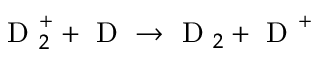Convert formula to latex. <formula><loc_0><loc_0><loc_500><loc_500>D _ { 2 } ^ { + } + D \rightarrow D _ { 2 } + D ^ { + }</formula> 